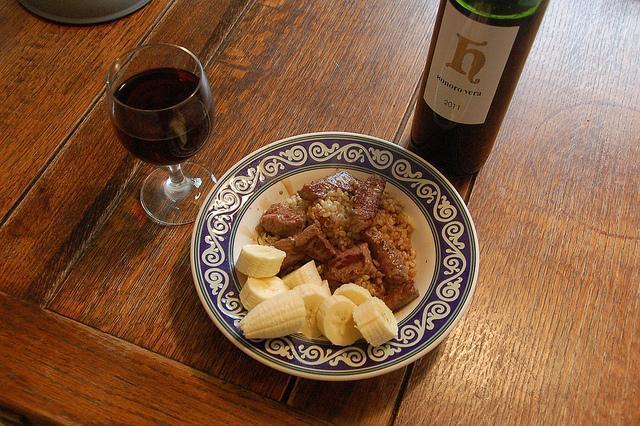Which item contains a lot of potassium?
Choose the right answer and clarify with the format: 'Answer: answer
Rationale: rationale.'
Options: Rice, banana, meat, wine. Answer: banana.
Rationale: The other options don't contain as much as a single a. 